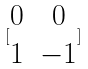Convert formula to latex. <formula><loc_0><loc_0><loc_500><loc_500>[ \begin{matrix} 0 & 0 \\ 1 & - 1 \end{matrix} ]</formula> 